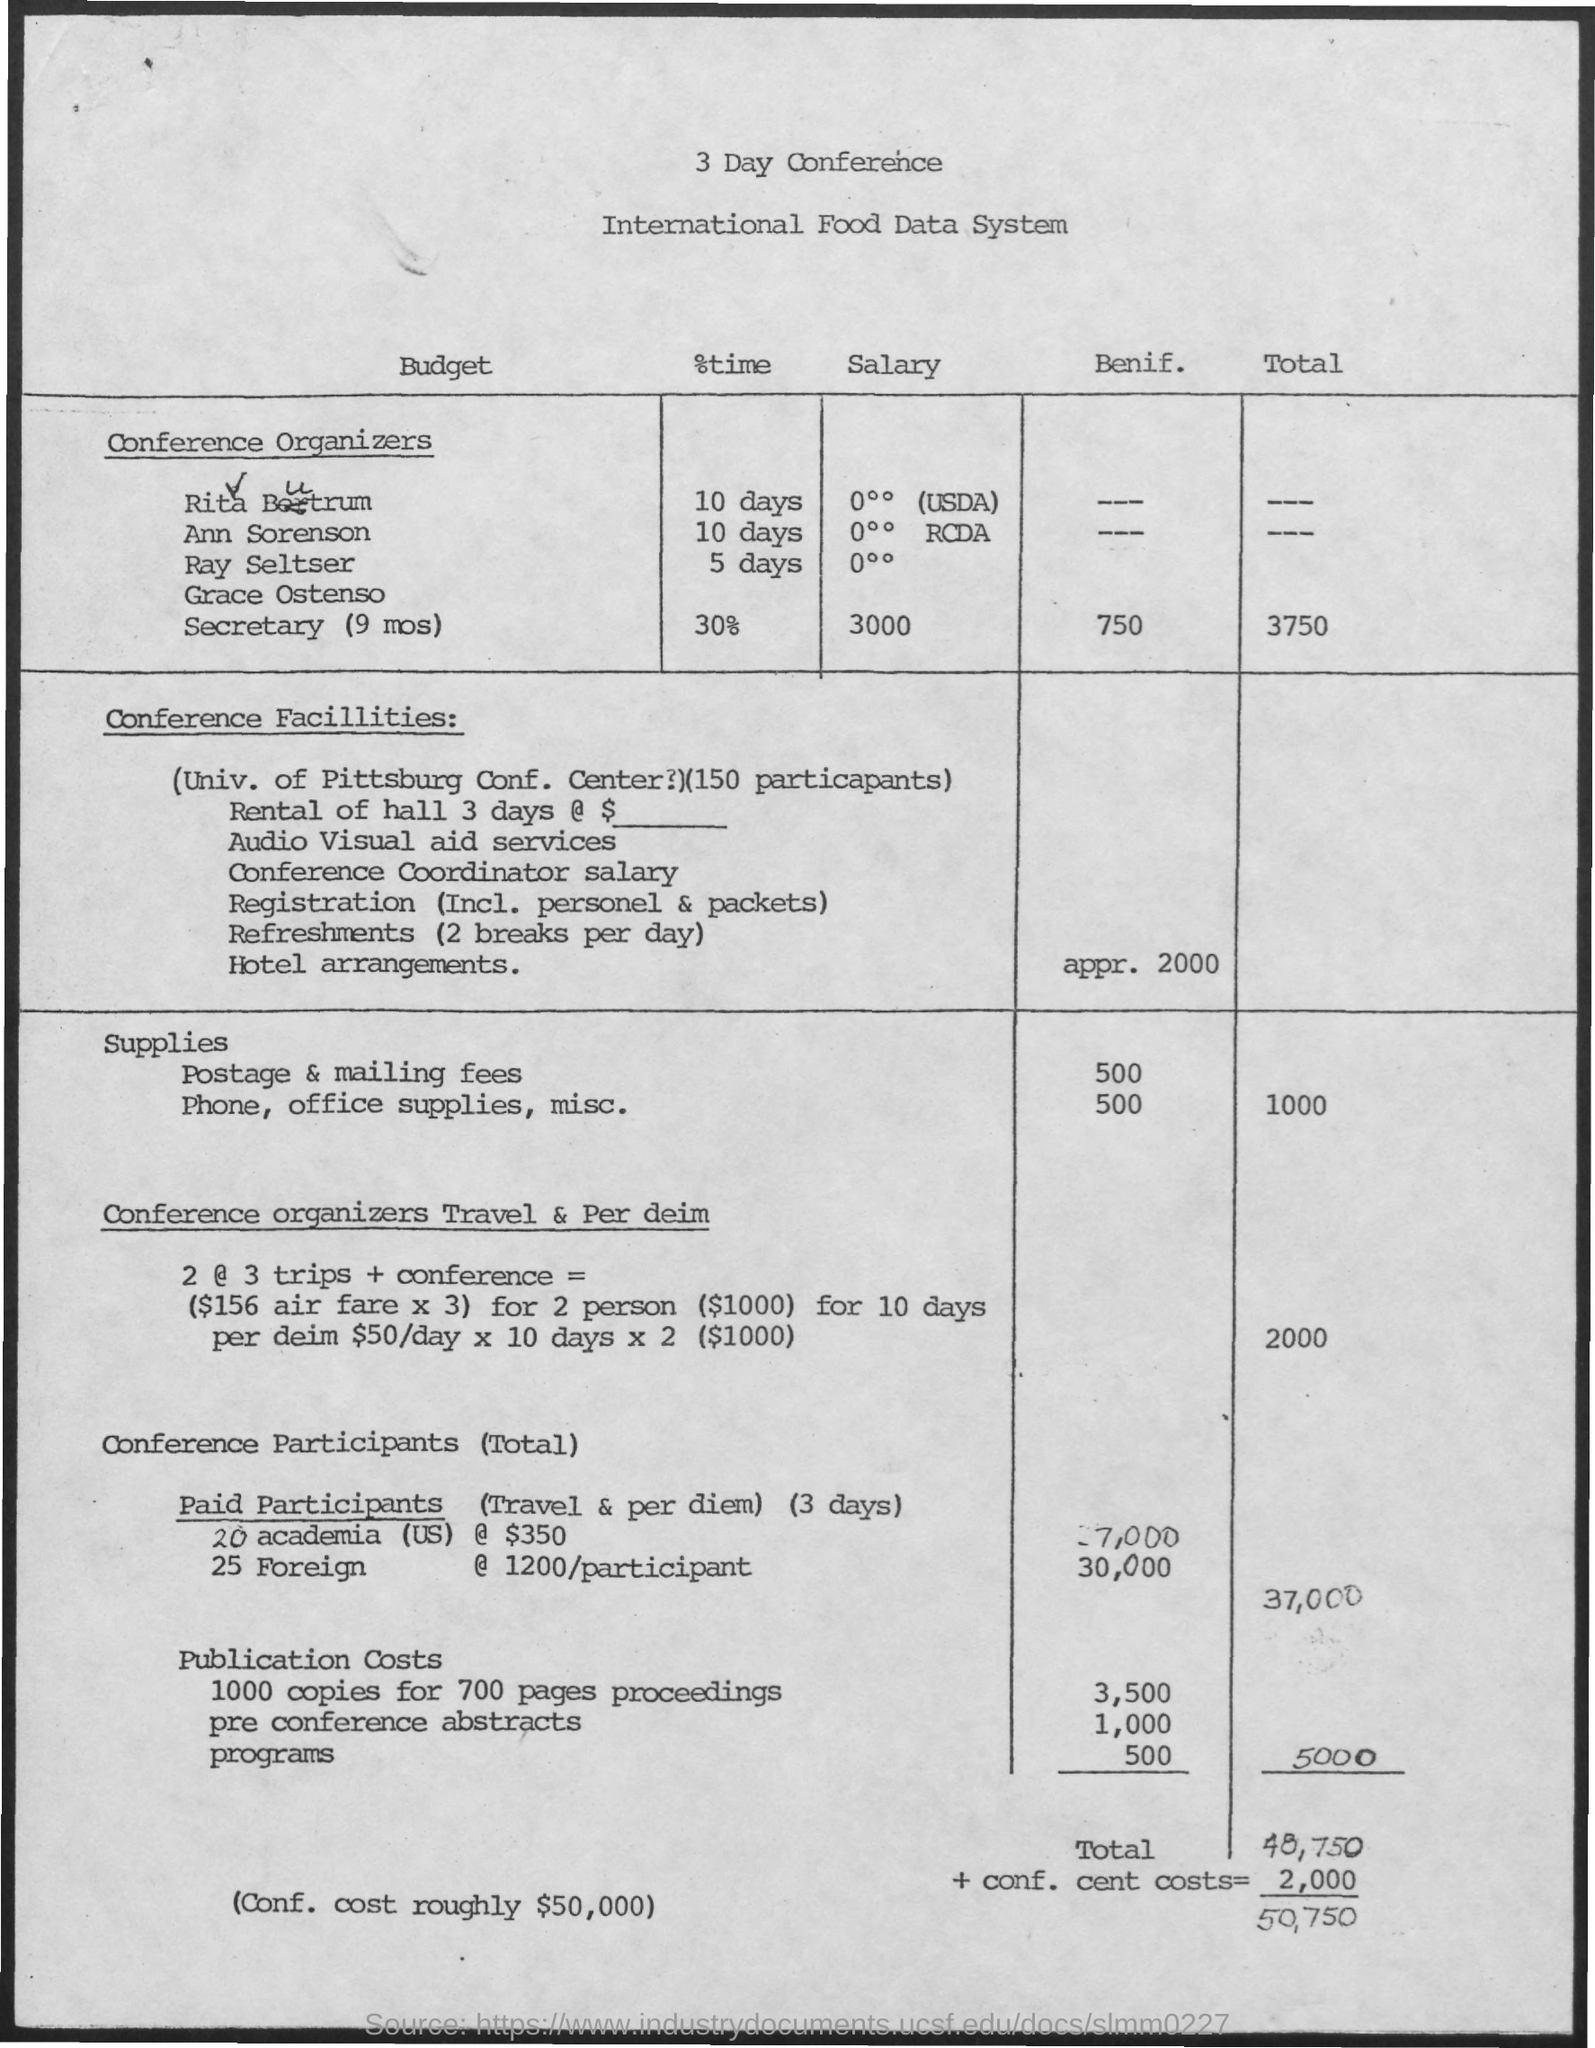How many days is the conference?
Provide a short and direct response. 3. 